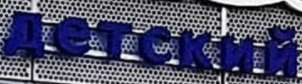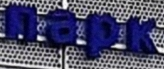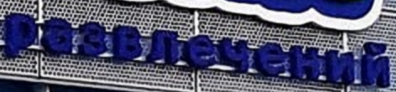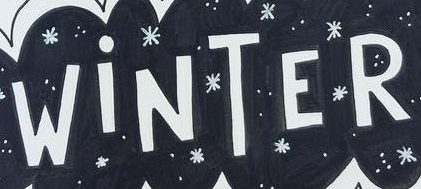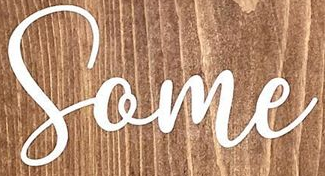What words can you see in these images in sequence, separated by a semicolon? детский; пapk; paзвлeчeний; WiNTER; Some 